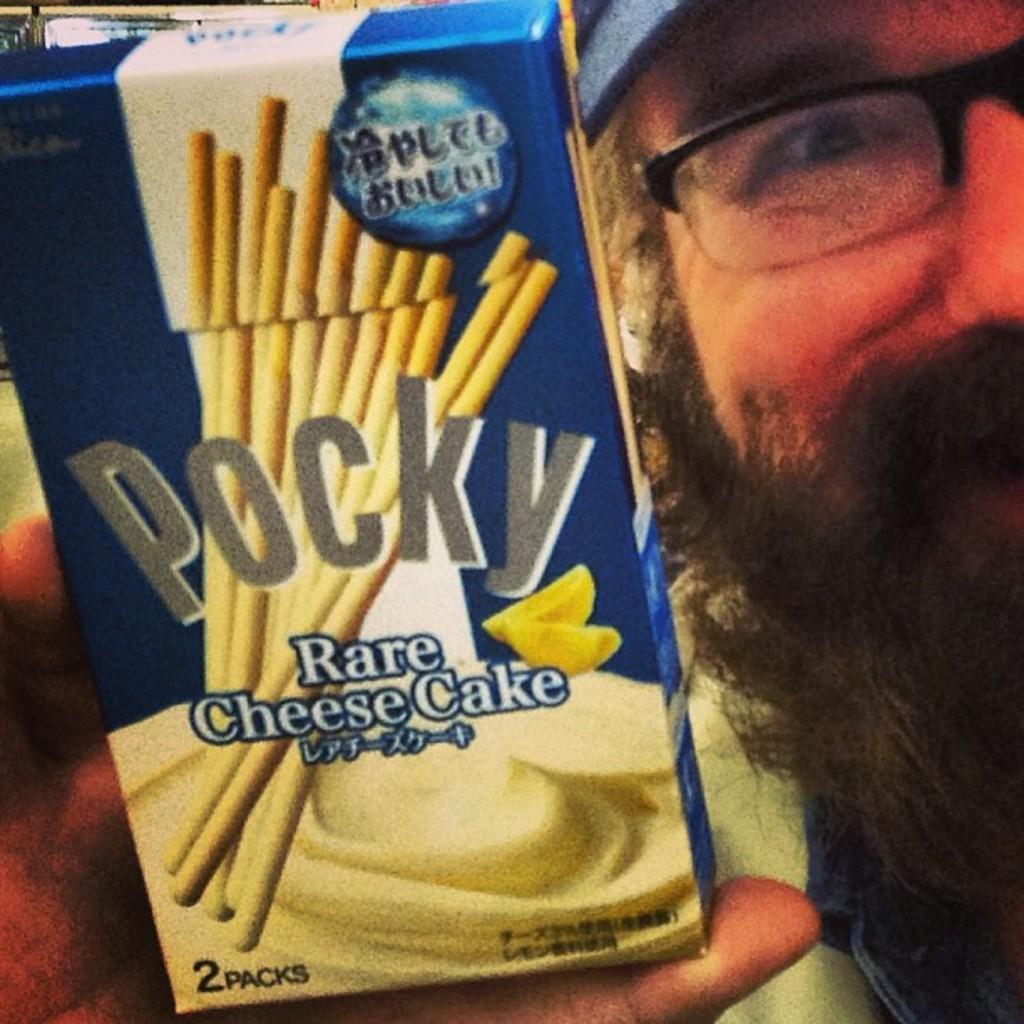In one or two sentences, can you explain what this image depicts? This is a zoomed in picture. On the right corner we can see a man wearing spectacles and holding a blue color box of a food item and we can see the text and some pictures on the box. In the background there are some objects. 